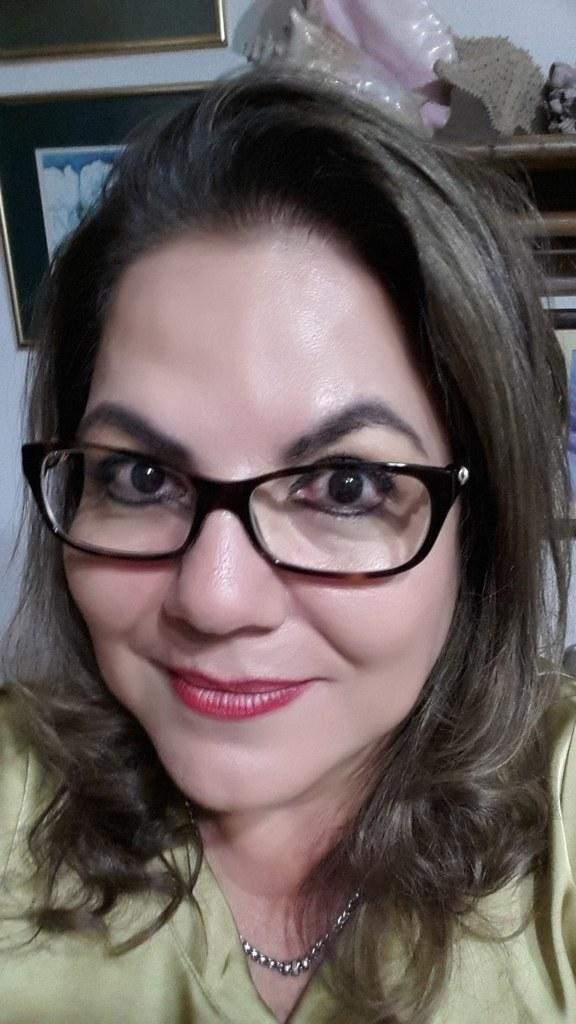Can you describe this image briefly? In this images in the foreground there is one woman who is wearing spectacles, and in the background there are photo frames and some objects and wall. 